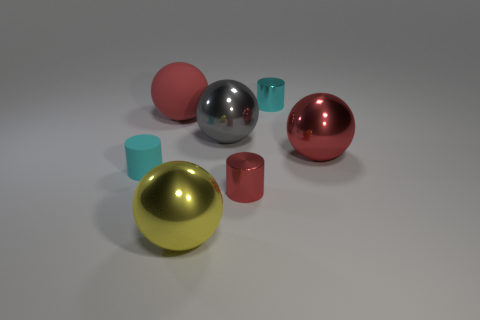Are there fewer matte cylinders than metal objects?
Your response must be concise. Yes. What color is the big metal object in front of the red object in front of the small rubber cylinder?
Offer a terse response. Yellow. What material is the gray object that is the same shape as the yellow object?
Ensure brevity in your answer.  Metal. What number of rubber things are either yellow things or gray objects?
Offer a very short reply. 0. Does the cyan cylinder that is to the right of the matte sphere have the same material as the tiny cyan cylinder that is in front of the red shiny sphere?
Ensure brevity in your answer.  No. Are any cyan metal objects visible?
Your answer should be compact. Yes. There is a cyan thing that is on the left side of the small cyan shiny thing; does it have the same shape as the small object on the right side of the small red cylinder?
Give a very brief answer. Yes. Are there any cyan cubes that have the same material as the gray thing?
Give a very brief answer. No. Is the cyan cylinder that is on the right side of the rubber cylinder made of the same material as the small red object?
Your answer should be very brief. Yes. Are there more small cylinders that are behind the large gray object than small shiny cylinders that are to the left of the big red matte sphere?
Offer a very short reply. Yes. 